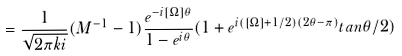<formula> <loc_0><loc_0><loc_500><loc_500>= \frac { 1 } { \sqrt { 2 \pi k i } } ( M ^ { - 1 } - 1 ) \frac { e ^ { - i [ \Omega ] \theta } } { 1 - e ^ { i \theta } } ( 1 + e ^ { i ( [ \Omega ] + 1 / 2 ) ( 2 \theta - \pi ) } t a n \theta / 2 )</formula> 